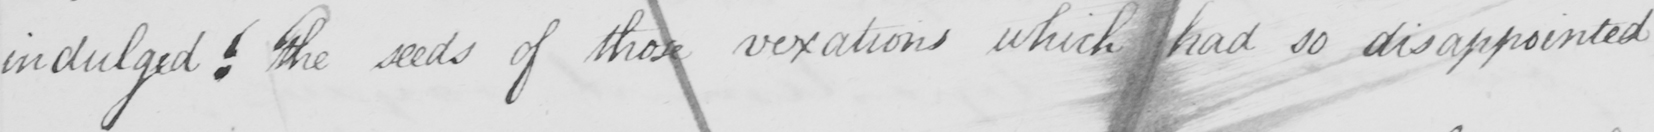What text is written in this handwritten line? indulged! The seeds of the vexations which had so disappointed 